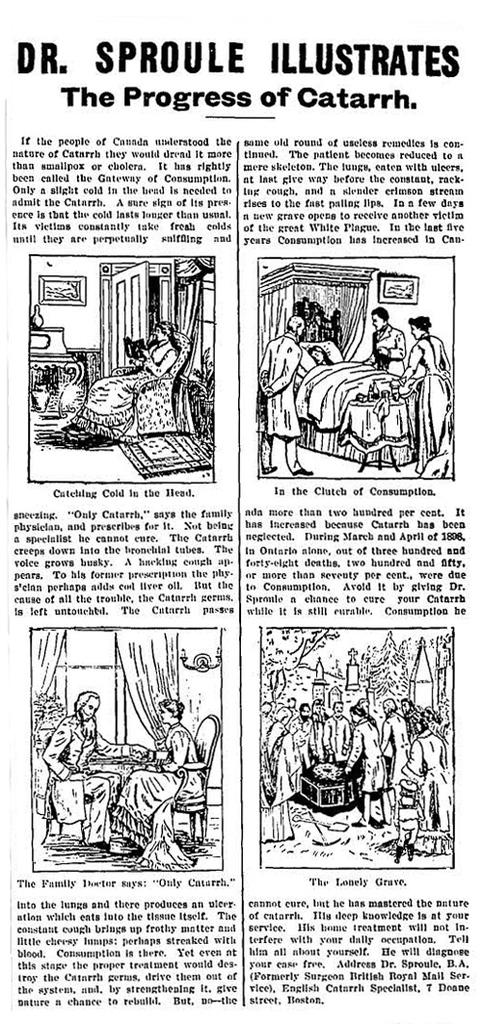What is present in the image? There is a paper in the image. What can be found on the paper? The paper has text on it and contains an art of a few persons. What type of quiet can be heard in the image? There is no sound present in the image, so it is not possible to determine what type of quiet might be heard. 